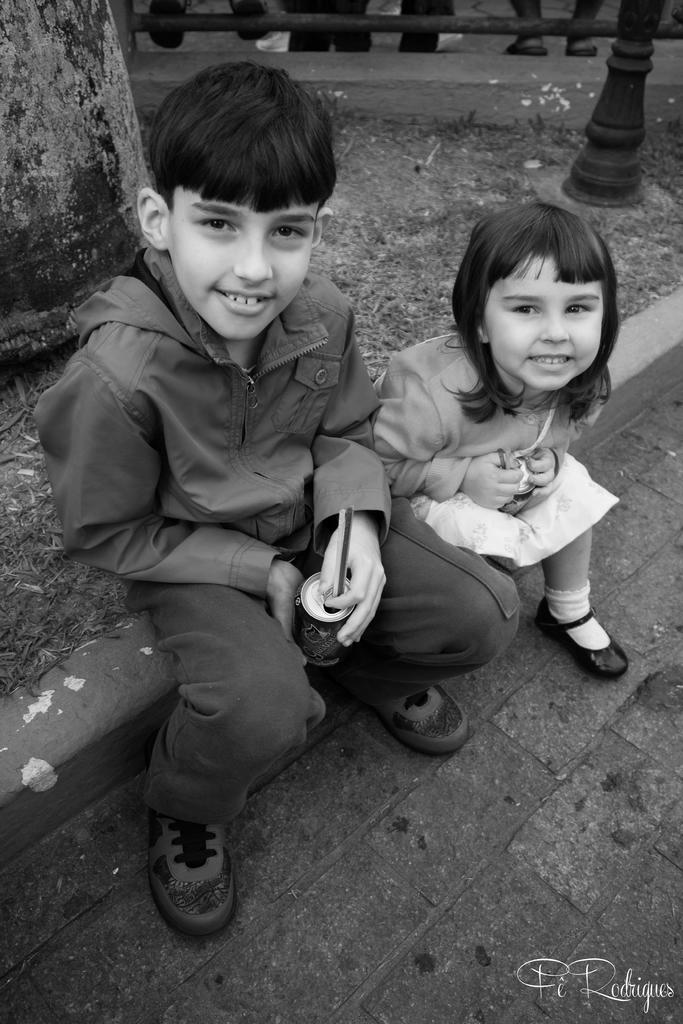How many children are in the image? There are two children in the image. What are the children doing in the image? The children are sitting on a small wall and smiling. What are the children holding in the image? The children are holding a can. What can be seen in the top right corner of the image? There is a pole in the top right corner of the image. What is present in the bottom right corner of the image? There is a watermark in the bottom right corner of the image. What type of harmony is being played by the children in the image? There is no indication of music or harmony in the image; the children are simply sitting on a wall and smiling. 